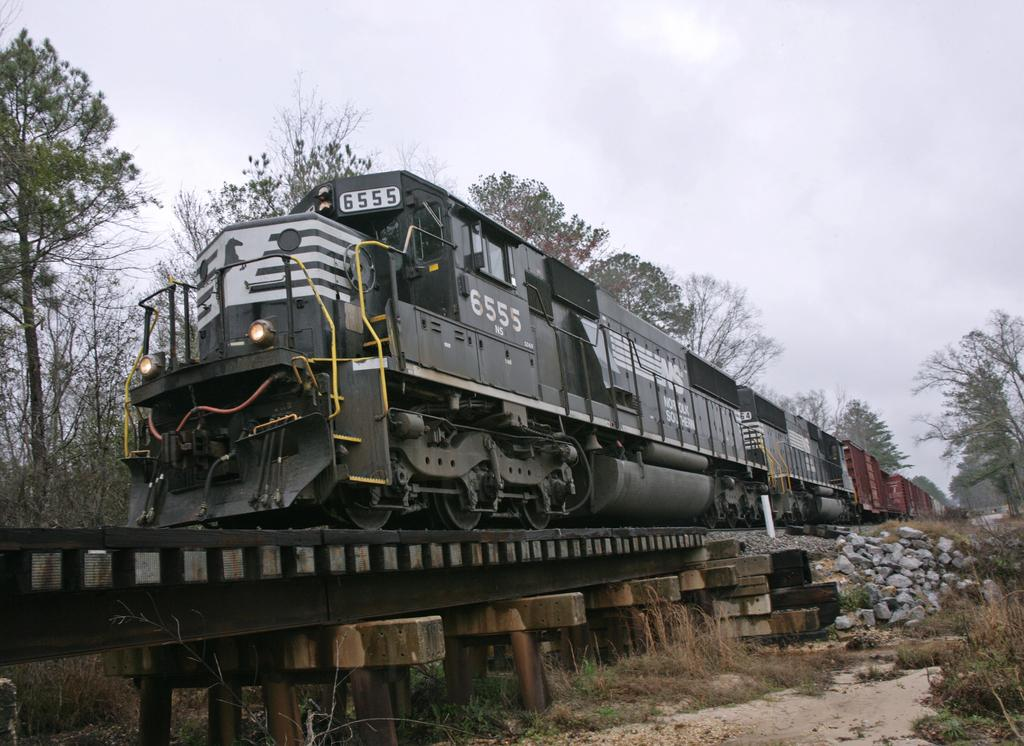What is the main subject in the foreground of the image? There is a train in the foreground of the image. What is the train's position in relation to the image? The train is on a track. What type of terrain can be seen in the image? There are stones, grass, and trees visible in the image. What is visible in the sky in the image? There are clouds visible in the image. What color is the tongue of the person sitting on the train in the image? There is no person sitting on the train in the image, and therefore no tongue is visible. What season is depicted in the image? The provided facts do not mention any specific season, so it cannot be determined from the image. 